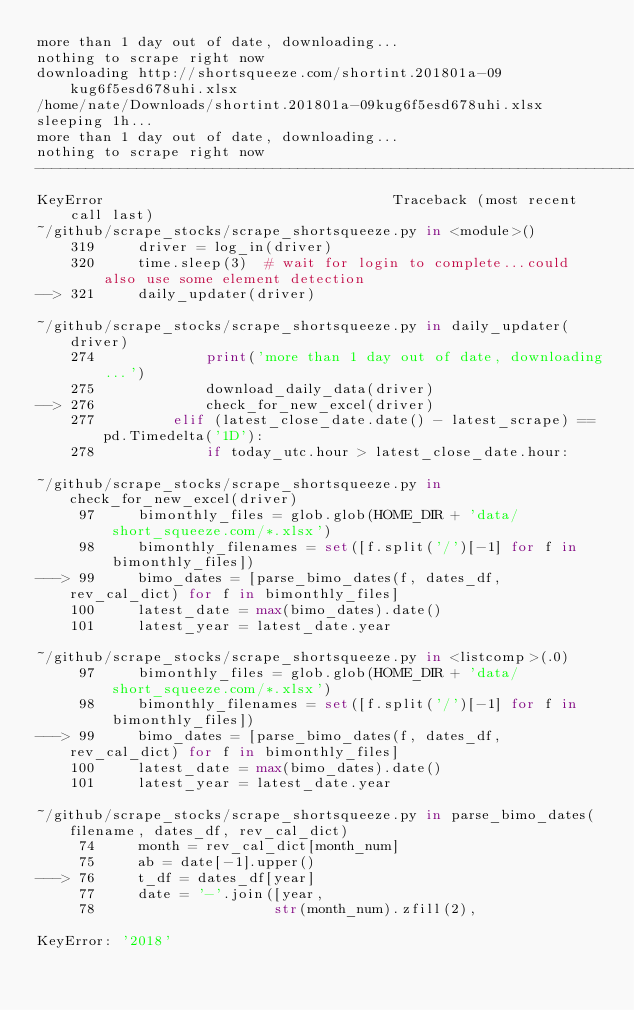Convert code to text. <code><loc_0><loc_0><loc_500><loc_500><_Python_>more than 1 day out of date, downloading...
nothing to scrape right now
downloading http://shortsqueeze.com/shortint.201801a-09kug6f5esd678uhi.xlsx
/home/nate/Downloads/shortint.201801a-09kug6f5esd678uhi.xlsx
sleeping 1h...
more than 1 day out of date, downloading...
nothing to scrape right now
---------------------------------------------------------------------------
KeyError                                  Traceback (most recent call last)
~/github/scrape_stocks/scrape_shortsqueeze.py in <module>()
    319     driver = log_in(driver)
    320     time.sleep(3)  # wait for login to complete...could also use some element detection
--> 321     daily_updater(driver)

~/github/scrape_stocks/scrape_shortsqueeze.py in daily_updater(driver)
    274             print('more than 1 day out of date, downloading...')
    275             download_daily_data(driver)
--> 276             check_for_new_excel(driver)
    277         elif (latest_close_date.date() - latest_scrape) == pd.Timedelta('1D'):
    278             if today_utc.hour > latest_close_date.hour:

~/github/scrape_stocks/scrape_shortsqueeze.py in check_for_new_excel(driver)
     97     bimonthly_files = glob.glob(HOME_DIR + 'data/short_squeeze.com/*.xlsx')
     98     bimonthly_filenames = set([f.split('/')[-1] for f in bimonthly_files])
---> 99     bimo_dates = [parse_bimo_dates(f, dates_df, rev_cal_dict) for f in bimonthly_files]
    100     latest_date = max(bimo_dates).date()
    101     latest_year = latest_date.year

~/github/scrape_stocks/scrape_shortsqueeze.py in <listcomp>(.0)
     97     bimonthly_files = glob.glob(HOME_DIR + 'data/short_squeeze.com/*.xlsx')
     98     bimonthly_filenames = set([f.split('/')[-1] for f in bimonthly_files])
---> 99     bimo_dates = [parse_bimo_dates(f, dates_df, rev_cal_dict) for f in bimonthly_files]
    100     latest_date = max(bimo_dates).date()
    101     latest_year = latest_date.year

~/github/scrape_stocks/scrape_shortsqueeze.py in parse_bimo_dates(filename, dates_df, rev_cal_dict)
     74     month = rev_cal_dict[month_num]
     75     ab = date[-1].upper()
---> 76     t_df = dates_df[year]
     77     date = '-'.join([year,
     78                     str(month_num).zfill(2),

KeyError: '2018'
</code> 